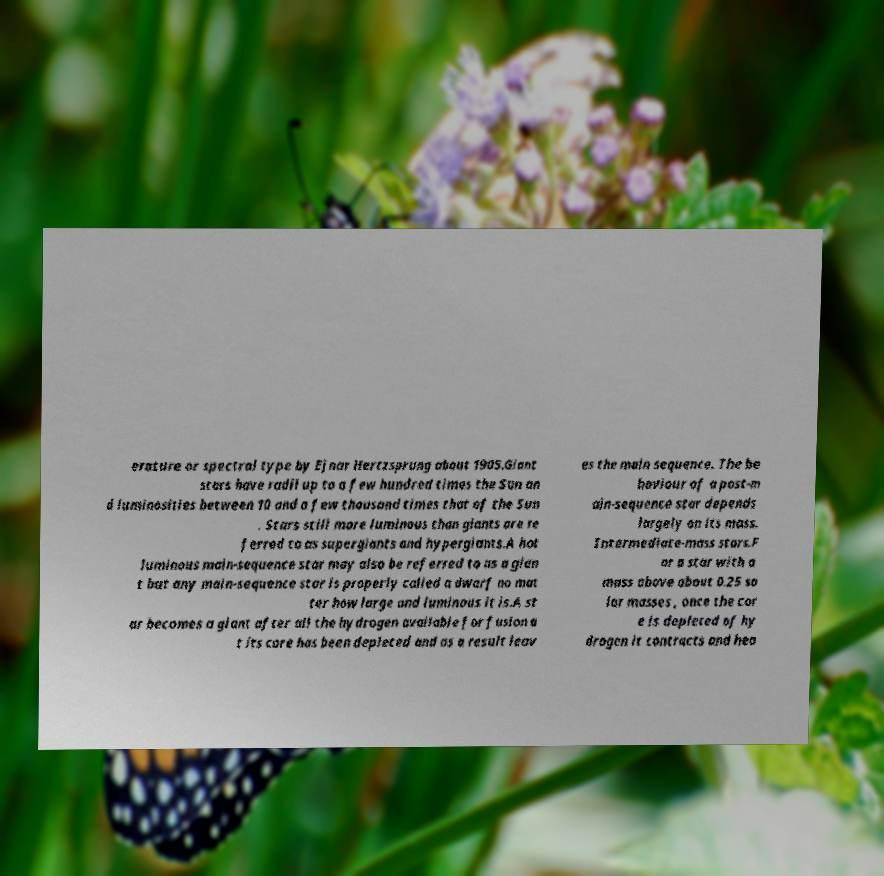Can you read and provide the text displayed in the image?This photo seems to have some interesting text. Can you extract and type it out for me? erature or spectral type by Ejnar Hertzsprung about 1905.Giant stars have radii up to a few hundred times the Sun an d luminosities between 10 and a few thousand times that of the Sun . Stars still more luminous than giants are re ferred to as supergiants and hypergiants.A hot luminous main-sequence star may also be referred to as a gian t but any main-sequence star is properly called a dwarf no mat ter how large and luminous it is.A st ar becomes a giant after all the hydrogen available for fusion a t its core has been depleted and as a result leav es the main sequence. The be haviour of a post-m ain-sequence star depends largely on its mass. Intermediate-mass stars.F or a star with a mass above about 0.25 so lar masses , once the cor e is depleted of hy drogen it contracts and hea 